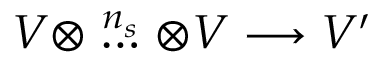Convert formula to latex. <formula><loc_0><loc_0><loc_500><loc_500>V \otimes \stackrel { n _ { s } } { \dots } \otimes V \longrightarrow V ^ { \prime }</formula> 